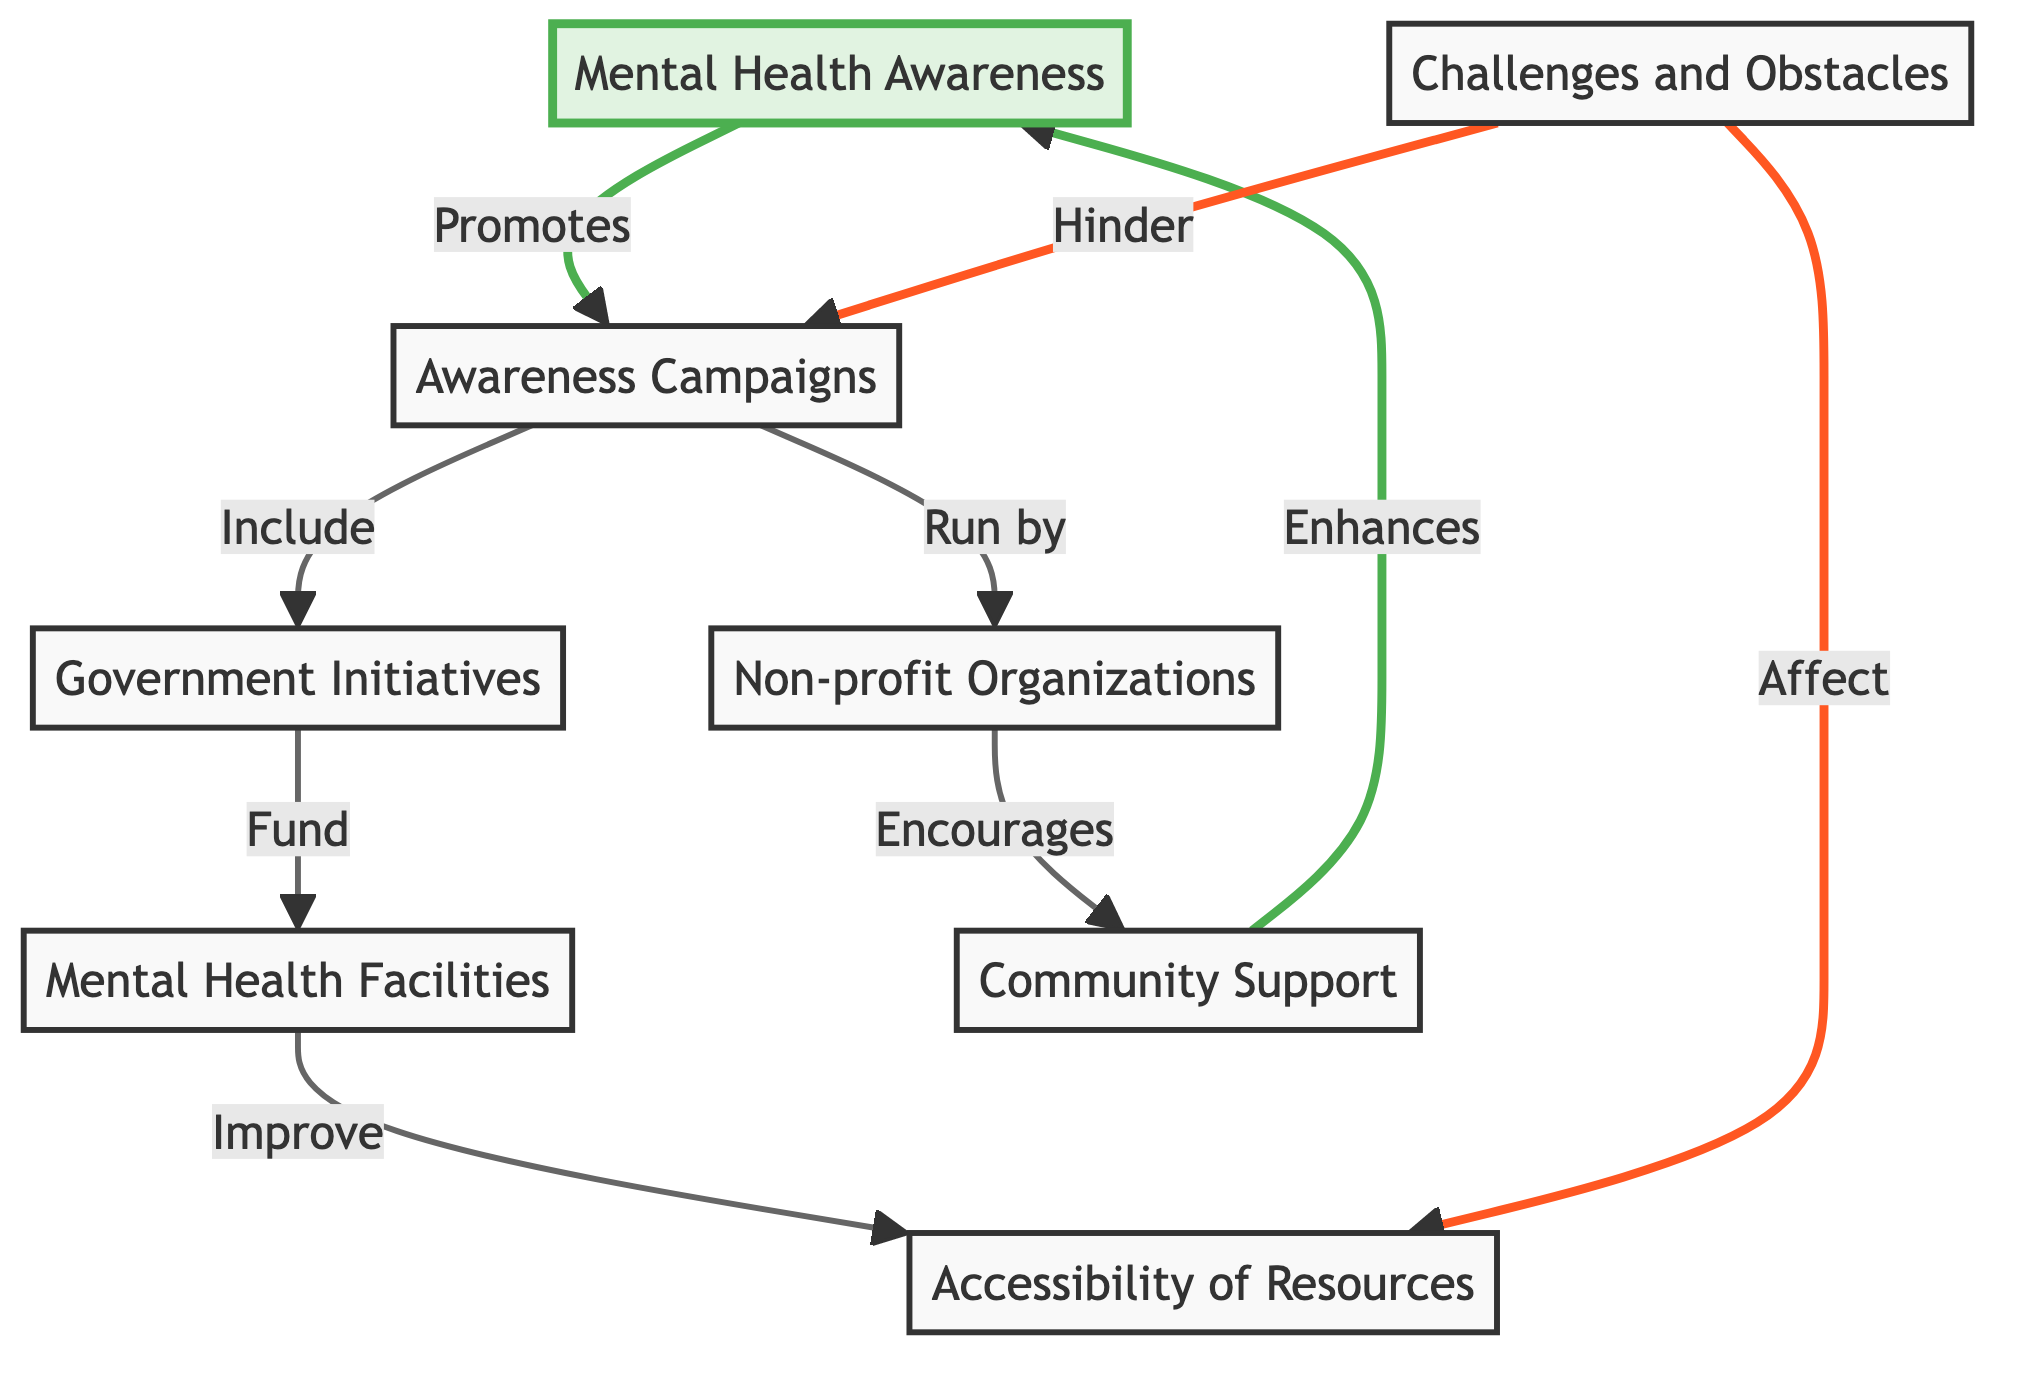What promotes awareness campaigns? The diagram shows that Mental Health Awareness promotes Awareness Campaigns. The flow indicates a direct connection from the Mental Health Awareness node to the Awareness Campaigns node.
Answer: Awareness Campaigns What enhances mental health awareness? According to the diagram, Community Support enhances Mental Health Awareness. This is indicated by the arrow going from Community Support to Mental Health Awareness.
Answer: Community Support How many types of organizations run awareness campaigns? The diagram mentions two types of organizations that run awareness campaigns: Government Initiatives and Non-profit Organizations. Each of these is represented distinctly in the diagram with their respective arrows pointing towards Awareness Campaigns.
Answer: Two What impacts accessibility of resources? The diagram illustrates that Challenges and Obstacles affect the Accessibility of Resources. The direct connection is visible from Challenges and Obstacles to Accessibility of Resources.
Answer: Challenges and Obstacles What do Government Initiatives fund? The flow in the diagram indicates that Government Initiatives fund Mental Health Facilities. The arrow clearly connects Government Initiatives to Mental Health Facilities.
Answer: Mental Health Facilities What does Community Support encourage? The diagram states that Non-profit Organizations encourage Community Support. The arrow from Non-profit Organizations to Community Support signifies this relationship.
Answer: Community Support What hinders awareness campaigns? The diagram clearly indicates that Challenges and Obstacles hinder Awareness Campaigns. There is a direct arrow from Challenges and Obstacles to Awareness Campaigns showing this relationship.
Answer: Challenges and Obstacles How does Mental Health Facilities improve accessibility? The diagram suggests that Mental Health Facilities improve Accessibility of Resources. The connection shows that the improvement in resources is a result of having adequate facilities.
Answer: Accessibility of Resources What is the role of Non-profit Organizations in mental health awareness? The diagram shows that Non-profit Organizations run Awareness Campaigns, indicating their active role in promoting mental health awareness via campaigns.
Answer: Run Awareness Campaigns 